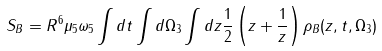<formula> <loc_0><loc_0><loc_500><loc_500>S _ { B } = R ^ { 6 } \mu _ { 5 } \omega _ { 5 } \int d t \int d \Omega _ { 3 } \int d z \frac { 1 } { 2 } \left ( z + \frac { 1 } { z } \right ) \rho _ { B } ( z , t , \Omega _ { 3 } )</formula> 